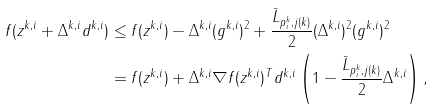<formula> <loc_0><loc_0><loc_500><loc_500>f ( z ^ { k , i } + \Delta ^ { k , i } d ^ { k , i } ) & \leq f ( z ^ { k , i } ) - \Delta ^ { k , i } ( g ^ { k , i } ) ^ { 2 } + \frac { \bar { L } _ { p ^ { k } _ { i } , j ( k ) } } 2 ( \Delta ^ { k , i } ) ^ { 2 } ( g ^ { k , i } ) ^ { 2 } \\ & = f ( z ^ { k , i } ) + \Delta ^ { k , i } \nabla f ( z ^ { k , i } ) ^ { T } d ^ { k , i } \left ( 1 - \frac { \bar { L } _ { p ^ { k } _ { i } , j ( k ) } } 2 \Delta ^ { k , i } \right ) ,</formula> 